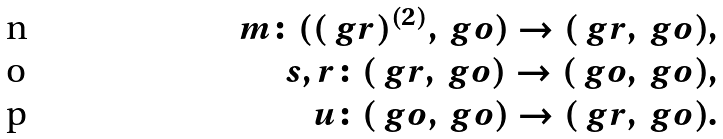<formula> <loc_0><loc_0><loc_500><loc_500>m \colon ( ( \ g r ) ^ { ( 2 ) } , \ g o ) \rightarrow ( \ g r , \ g o ) , \\ s , r \colon ( \ g r , \ g o ) \rightarrow ( \ g o , \ g o ) , \\ u \colon ( \ g o , \ g o ) \rightarrow ( \ g r , \ g o ) .</formula> 